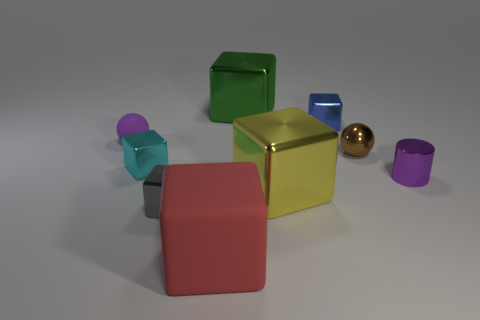There is a large thing that is behind the cylinder; is it the same shape as the blue metal thing?
Your answer should be compact. Yes. Are there more tiny gray objects to the right of the cylinder than gray shiny things?
Make the answer very short. No. There is a tiny sphere behind the small brown object; is its color the same as the cylinder?
Keep it short and to the point. Yes. Is there anything else of the same color as the shiny sphere?
Your answer should be very brief. No. The large thing that is behind the small object to the right of the ball that is in front of the small purple matte ball is what color?
Provide a succinct answer. Green. Is the yellow object the same size as the cyan shiny block?
Your answer should be very brief. No. How many cyan shiny blocks are the same size as the gray object?
Your response must be concise. 1. What shape is the tiny object that is the same color as the tiny shiny cylinder?
Give a very brief answer. Sphere. Do the big thing behind the small purple rubber thing and the sphere on the left side of the tiny brown metallic object have the same material?
Make the answer very short. No. Are there any other things that have the same shape as the green shiny object?
Your response must be concise. Yes. 